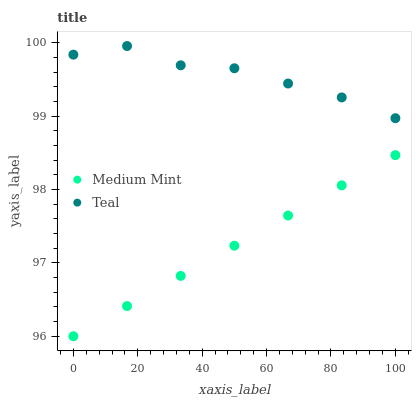Does Medium Mint have the minimum area under the curve?
Answer yes or no. Yes. Does Teal have the maximum area under the curve?
Answer yes or no. Yes. Does Teal have the minimum area under the curve?
Answer yes or no. No. Is Medium Mint the smoothest?
Answer yes or no. Yes. Is Teal the roughest?
Answer yes or no. Yes. Is Teal the smoothest?
Answer yes or no. No. Does Medium Mint have the lowest value?
Answer yes or no. Yes. Does Teal have the lowest value?
Answer yes or no. No. Does Teal have the highest value?
Answer yes or no. Yes. Is Medium Mint less than Teal?
Answer yes or no. Yes. Is Teal greater than Medium Mint?
Answer yes or no. Yes. Does Medium Mint intersect Teal?
Answer yes or no. No. 